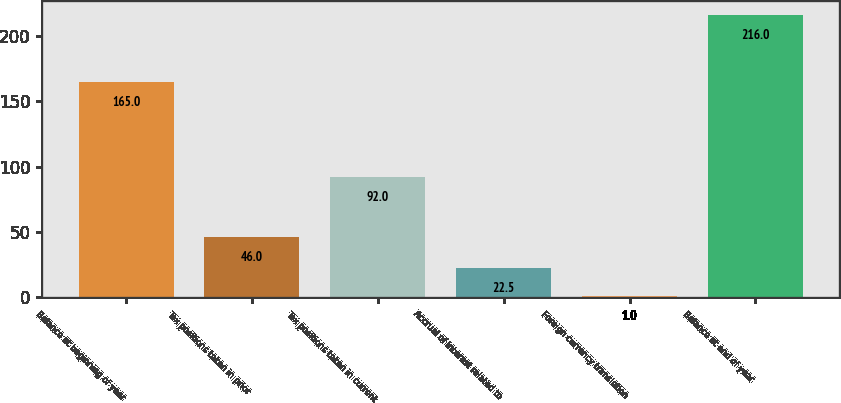Convert chart. <chart><loc_0><loc_0><loc_500><loc_500><bar_chart><fcel>Balance at beginning of year<fcel>Tax positions taken in prior<fcel>Tax positions taken in current<fcel>Accrual of interest related to<fcel>Foreign currency translation<fcel>Balance at end of year<nl><fcel>165<fcel>46<fcel>92<fcel>22.5<fcel>1<fcel>216<nl></chart> 